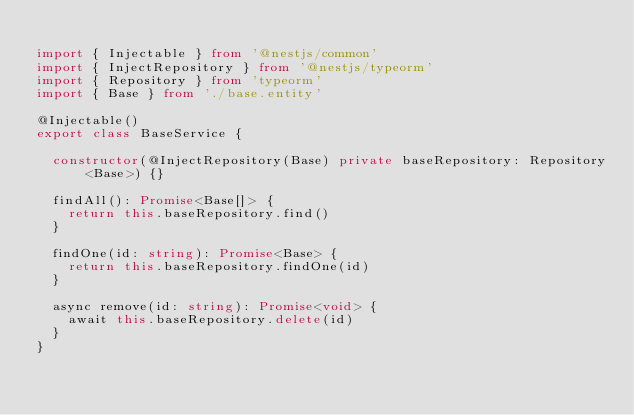Convert code to text. <code><loc_0><loc_0><loc_500><loc_500><_TypeScript_>
import { Injectable } from '@nestjs/common'
import { InjectRepository } from '@nestjs/typeorm'
import { Repository } from 'typeorm'
import { Base } from './base.entity'

@Injectable()
export class BaseService {
    
  constructor(@InjectRepository(Base) private baseRepository: Repository<Base>) {}

  findAll(): Promise<Base[]> {
    return this.baseRepository.find()
  }

  findOne(id: string): Promise<Base> {
    return this.baseRepository.findOne(id)
  }

  async remove(id: string): Promise<void> {
    await this.baseRepository.delete(id)
  }
}

</code> 